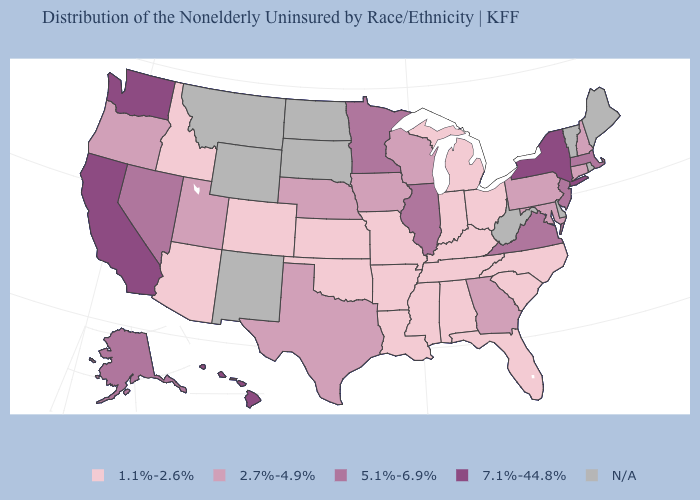Among the states that border Nebraska , which have the highest value?
Answer briefly. Iowa. What is the value of Kansas?
Be succinct. 1.1%-2.6%. How many symbols are there in the legend?
Be succinct. 5. What is the highest value in the West ?
Be succinct. 7.1%-44.8%. Does Connecticut have the lowest value in the Northeast?
Write a very short answer. Yes. What is the value of West Virginia?
Write a very short answer. N/A. What is the highest value in the South ?
Write a very short answer. 5.1%-6.9%. What is the value of Oklahoma?
Be succinct. 1.1%-2.6%. Which states have the highest value in the USA?
Be succinct. California, Hawaii, New York, Washington. Does Washington have the highest value in the USA?
Answer briefly. Yes. Among the states that border New Mexico , does Oklahoma have the highest value?
Short answer required. No. What is the value of New Mexico?
Answer briefly. N/A. Does California have the highest value in the USA?
Be succinct. Yes. What is the lowest value in the USA?
Short answer required. 1.1%-2.6%. 